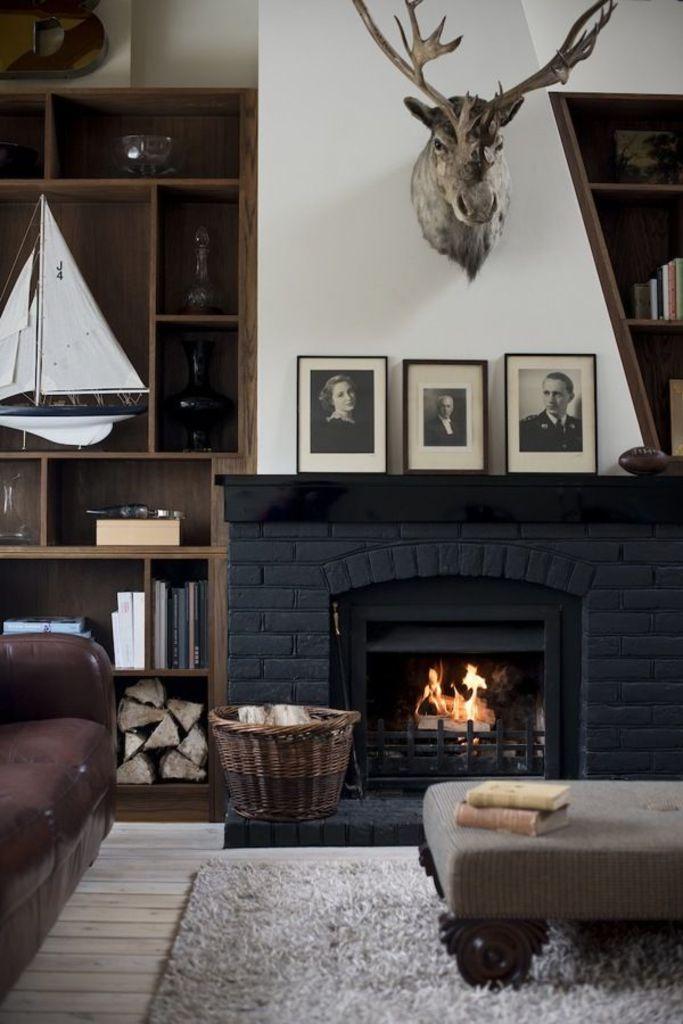Describe this image in one or two sentences. In the image on the left we can see couch. On the right we can see table and on the bottom there is a carpet. Coming to background we can see photo frame,wall,fire,basket, shelf with full of books etc. 